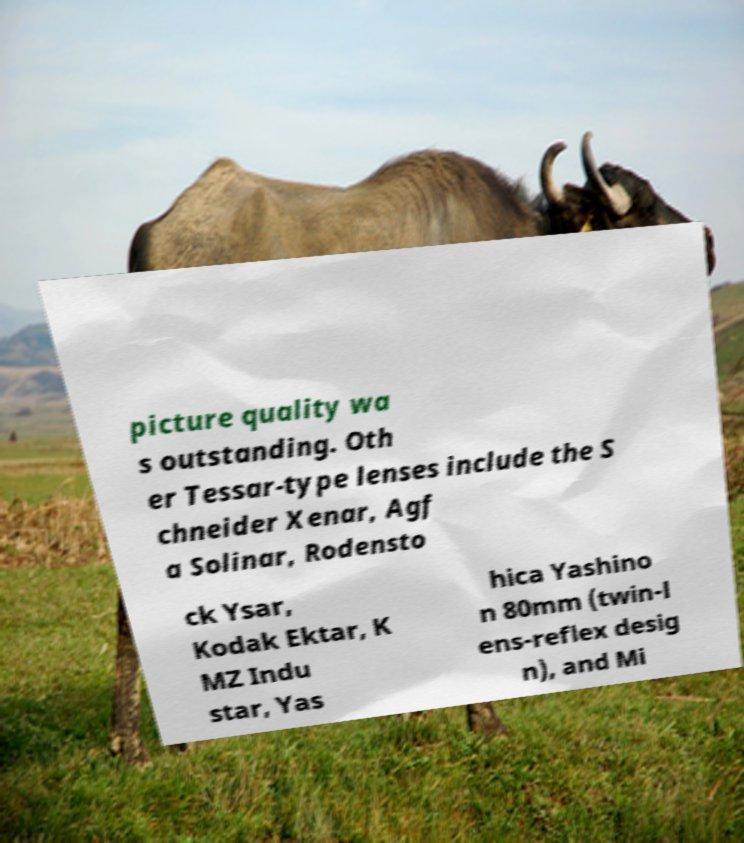Can you accurately transcribe the text from the provided image for me? picture quality wa s outstanding. Oth er Tessar-type lenses include the S chneider Xenar, Agf a Solinar, Rodensto ck Ysar, Kodak Ektar, K MZ Indu star, Yas hica Yashino n 80mm (twin-l ens-reflex desig n), and Mi 